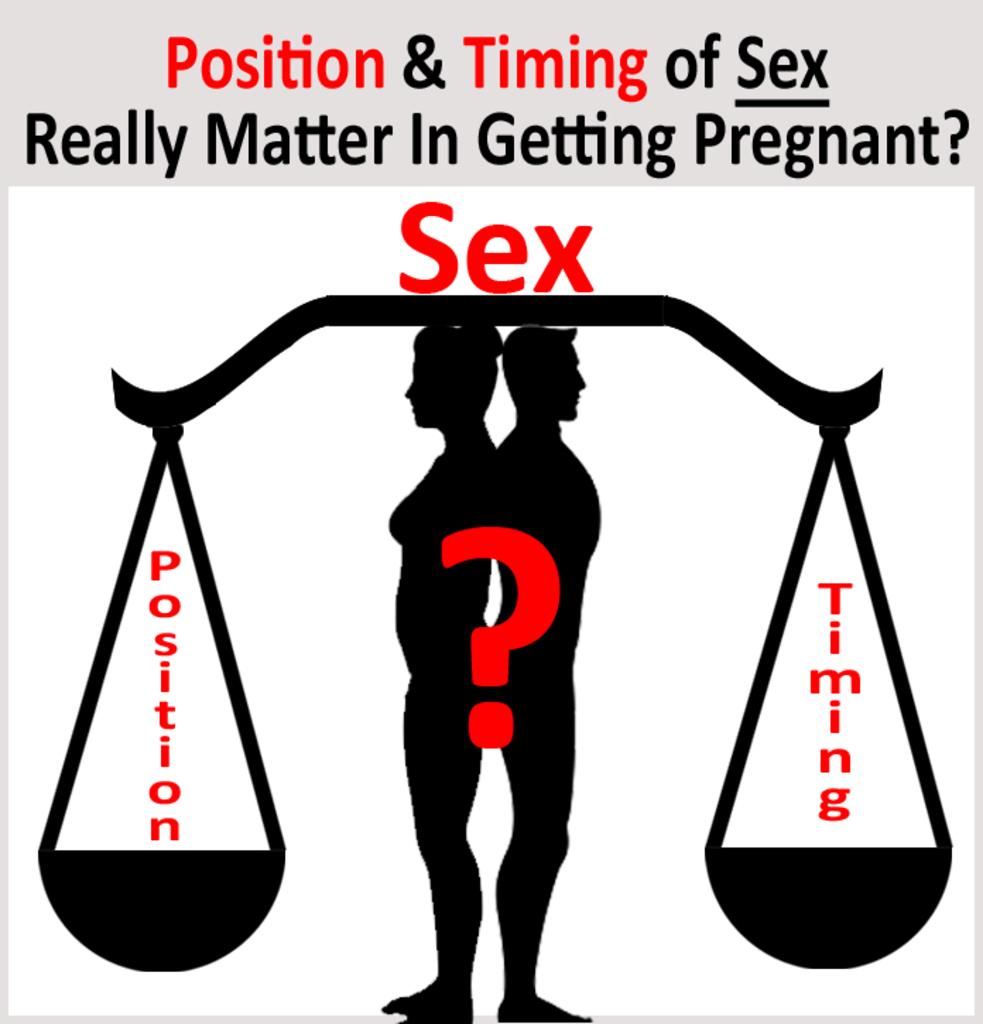What two things are being discussed in regards to pregnancy?
Your response must be concise. Position timing. What really matters when getting pregnant according to this poster?
Keep it short and to the point. Position and timing. 